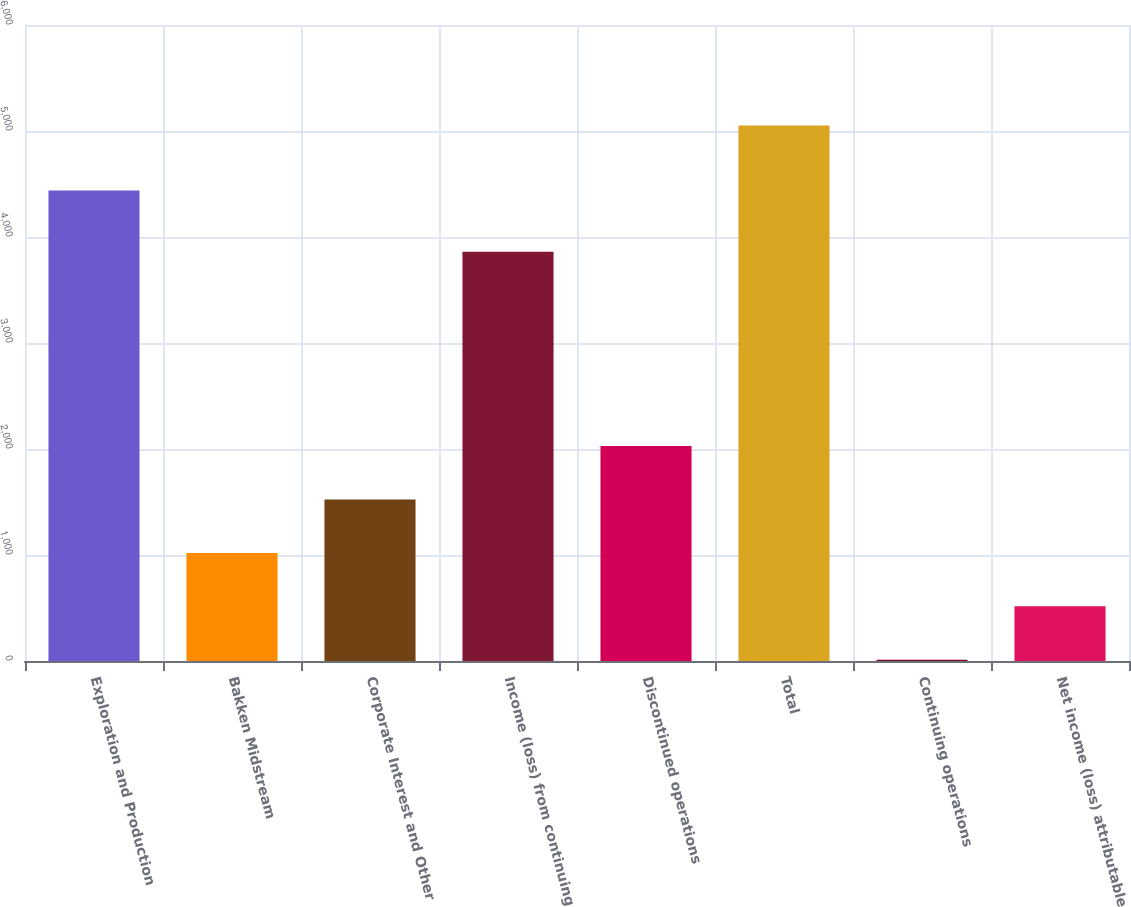Convert chart to OTSL. <chart><loc_0><loc_0><loc_500><loc_500><bar_chart><fcel>Exploration and Production<fcel>Bakken Midstream<fcel>Corporate Interest and Other<fcel>Income (loss) from continuing<fcel>Discontinued operations<fcel>Total<fcel>Continuing operations<fcel>Net income (loss) attributable<nl><fcel>4439<fcel>1019.47<fcel>1523.54<fcel>3860<fcel>2027.61<fcel>5052<fcel>11.33<fcel>515.4<nl></chart> 